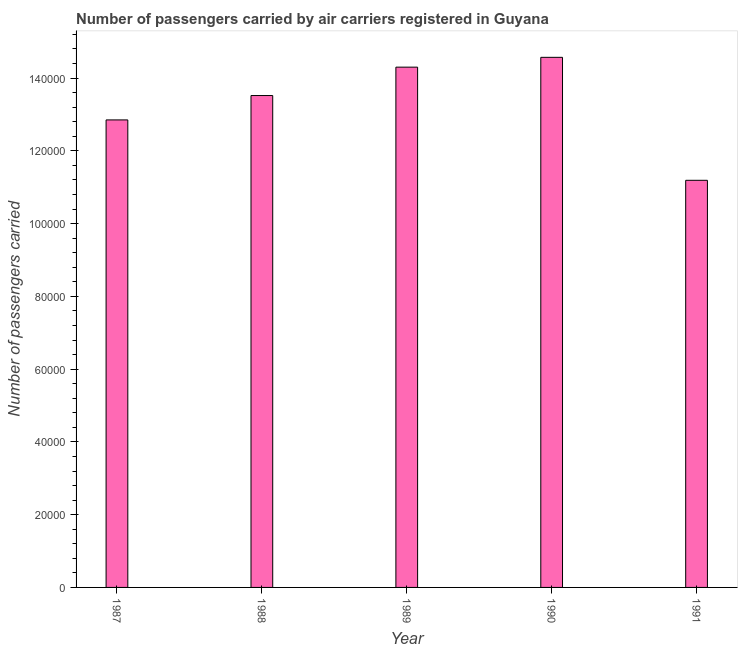Does the graph contain any zero values?
Keep it short and to the point. No. Does the graph contain grids?
Your answer should be very brief. No. What is the title of the graph?
Offer a terse response. Number of passengers carried by air carriers registered in Guyana. What is the label or title of the X-axis?
Offer a terse response. Year. What is the label or title of the Y-axis?
Provide a succinct answer. Number of passengers carried. What is the number of passengers carried in 1991?
Offer a very short reply. 1.12e+05. Across all years, what is the maximum number of passengers carried?
Keep it short and to the point. 1.46e+05. Across all years, what is the minimum number of passengers carried?
Ensure brevity in your answer.  1.12e+05. In which year was the number of passengers carried maximum?
Your response must be concise. 1990. In which year was the number of passengers carried minimum?
Give a very brief answer. 1991. What is the sum of the number of passengers carried?
Make the answer very short. 6.64e+05. What is the difference between the number of passengers carried in 1987 and 1988?
Offer a very short reply. -6700. What is the average number of passengers carried per year?
Offer a very short reply. 1.33e+05. What is the median number of passengers carried?
Your answer should be compact. 1.35e+05. In how many years, is the number of passengers carried greater than 64000 ?
Give a very brief answer. 5. Do a majority of the years between 1991 and 1988 (inclusive) have number of passengers carried greater than 8000 ?
Your answer should be very brief. Yes. What is the ratio of the number of passengers carried in 1988 to that in 1989?
Provide a short and direct response. 0.94. Is the number of passengers carried in 1989 less than that in 1991?
Your response must be concise. No. What is the difference between the highest and the second highest number of passengers carried?
Your answer should be very brief. 2700. What is the difference between the highest and the lowest number of passengers carried?
Your response must be concise. 3.38e+04. How many bars are there?
Provide a succinct answer. 5. What is the difference between two consecutive major ticks on the Y-axis?
Your response must be concise. 2.00e+04. What is the Number of passengers carried of 1987?
Your response must be concise. 1.28e+05. What is the Number of passengers carried in 1988?
Offer a very short reply. 1.35e+05. What is the Number of passengers carried of 1989?
Ensure brevity in your answer.  1.43e+05. What is the Number of passengers carried in 1990?
Offer a very short reply. 1.46e+05. What is the Number of passengers carried in 1991?
Offer a very short reply. 1.12e+05. What is the difference between the Number of passengers carried in 1987 and 1988?
Provide a succinct answer. -6700. What is the difference between the Number of passengers carried in 1987 and 1989?
Your answer should be compact. -1.45e+04. What is the difference between the Number of passengers carried in 1987 and 1990?
Your response must be concise. -1.72e+04. What is the difference between the Number of passengers carried in 1987 and 1991?
Provide a succinct answer. 1.66e+04. What is the difference between the Number of passengers carried in 1988 and 1989?
Your answer should be compact. -7800. What is the difference between the Number of passengers carried in 1988 and 1990?
Offer a very short reply. -1.05e+04. What is the difference between the Number of passengers carried in 1988 and 1991?
Offer a terse response. 2.33e+04. What is the difference between the Number of passengers carried in 1989 and 1990?
Give a very brief answer. -2700. What is the difference between the Number of passengers carried in 1989 and 1991?
Provide a succinct answer. 3.11e+04. What is the difference between the Number of passengers carried in 1990 and 1991?
Your response must be concise. 3.38e+04. What is the ratio of the Number of passengers carried in 1987 to that in 1988?
Your response must be concise. 0.95. What is the ratio of the Number of passengers carried in 1987 to that in 1989?
Your response must be concise. 0.9. What is the ratio of the Number of passengers carried in 1987 to that in 1990?
Give a very brief answer. 0.88. What is the ratio of the Number of passengers carried in 1987 to that in 1991?
Provide a short and direct response. 1.15. What is the ratio of the Number of passengers carried in 1988 to that in 1989?
Ensure brevity in your answer.  0.94. What is the ratio of the Number of passengers carried in 1988 to that in 1990?
Your response must be concise. 0.93. What is the ratio of the Number of passengers carried in 1988 to that in 1991?
Your response must be concise. 1.21. What is the ratio of the Number of passengers carried in 1989 to that in 1991?
Give a very brief answer. 1.28. What is the ratio of the Number of passengers carried in 1990 to that in 1991?
Your answer should be very brief. 1.3. 